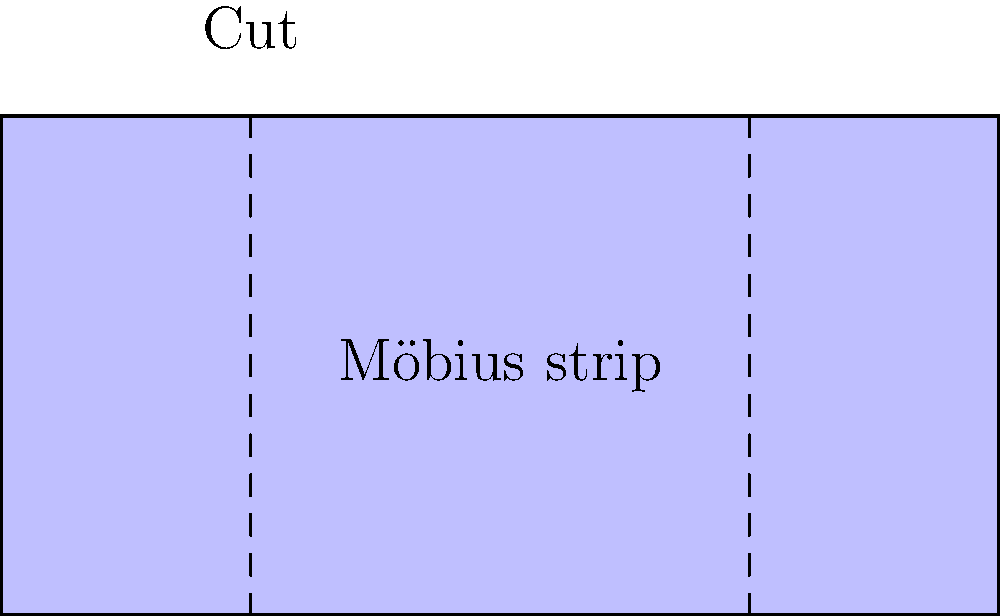As a concerned parent, you're researching educational toys for your child. You come across a Möbius strip and wonder about its practical applications. If you were to cut a Möbius strip lengthwise down the middle, what would be the result, and how might this demonstrate the government's overreach in regulating children's toys? To understand the result of cutting a Möbius strip lengthwise, let's follow these steps:

1. A Möbius strip is a surface with only one side and one edge, created by taking a strip of paper, giving it a half-twist, and joining the ends.

2. When you cut a Möbius strip lengthwise down the middle:
   a. You might expect it to split into two separate loops.
   b. However, it actually remains in one piece.

3. The resulting shape after cutting:
   a. Is twice as long as the original strip.
   b. Has two full twists instead of one half-twist.
   c. Is thinner than the original strip.

4. This unexpected result demonstrates the unique topological properties of the Möbius strip.

5. Relating to government overreach:
   a. The Möbius strip's behavior defies common expectations, much like how excessive regulations can have unintended consequences.
   b. Just as cutting the strip doesn't separate it, more regulations don't necessarily make toys safer.
   c. The complexity of the result mirrors how overregulation can complicate simple concepts or products.

6. This example shows that:
   a. Simple objects can have complex properties.
   b. Intuition doesn't always predict outcomes accurately.
   c. Interfering with a system (like cutting the strip or over-regulating toys) can lead to unexpected results.

The Möbius strip demonstrates that sometimes, less intervention leads to simpler, more understandable outcomes, which can be applied to the argument against excessive toy regulations.
Answer: One longer loop with two full twists 